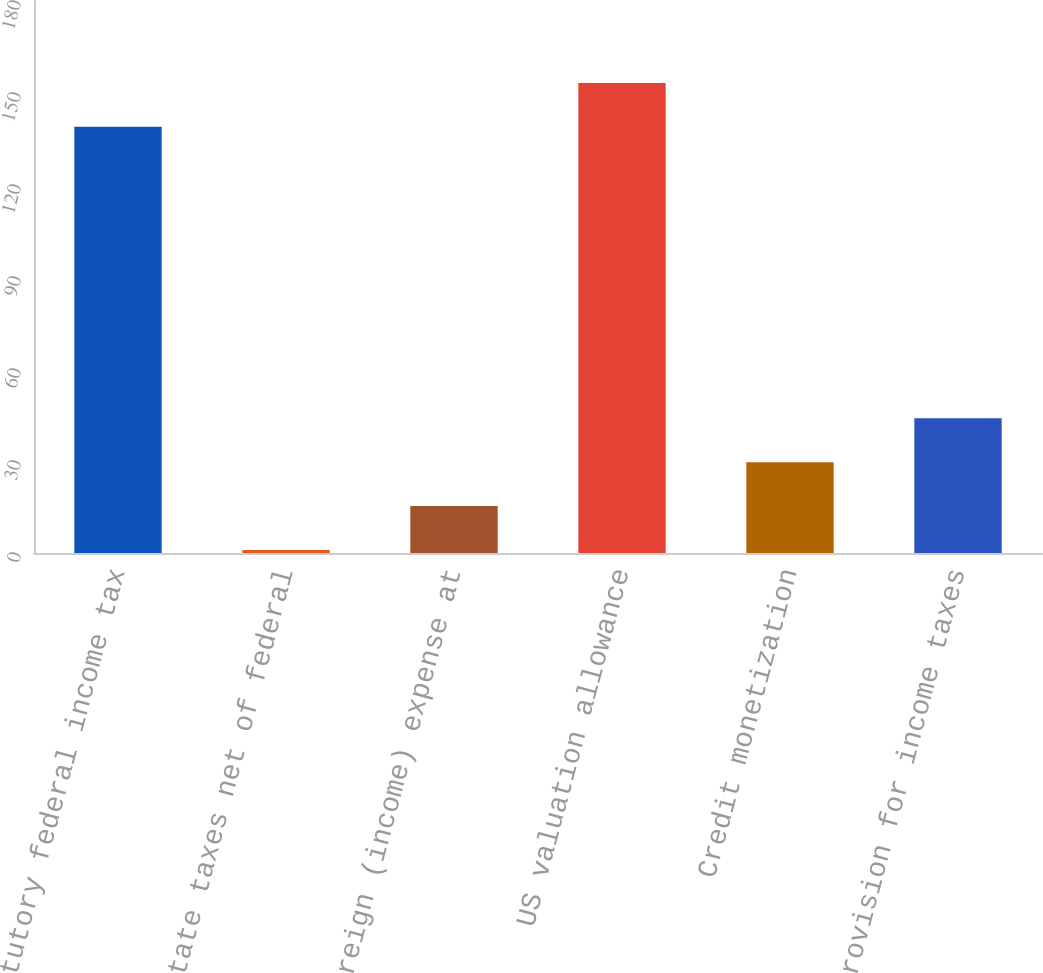Convert chart. <chart><loc_0><loc_0><loc_500><loc_500><bar_chart><fcel>Statutory federal income tax<fcel>State taxes net of federal<fcel>Foreign (income) expense at<fcel>US valuation allowance<fcel>Credit monetization<fcel>Provision for income taxes<nl><fcel>139<fcel>1<fcel>15.3<fcel>153.3<fcel>29.6<fcel>43.9<nl></chart> 